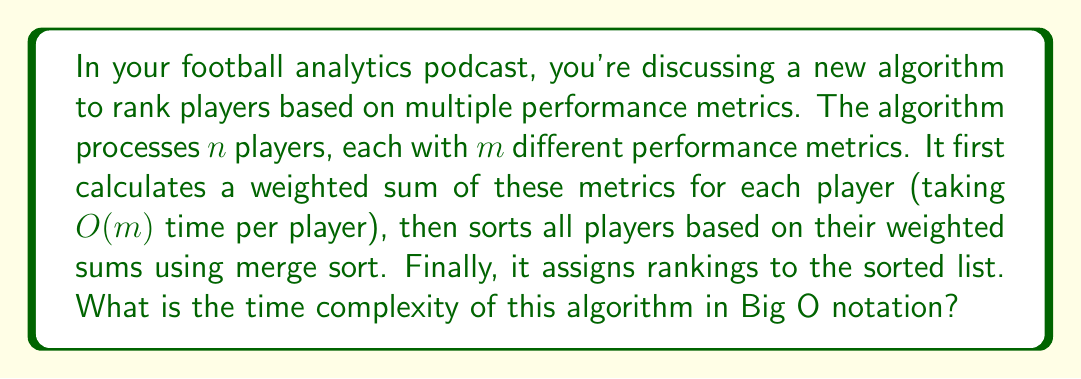Provide a solution to this math problem. Let's break down the algorithm and analyze its time complexity step by step:

1. Calculating weighted sums:
   - For each of the $n$ players, we perform $m$ operations to calculate the weighted sum.
   - Time complexity for this step: $O(n * m)$

2. Sorting players using merge sort:
   - Merge sort has a time complexity of $O(n \log n)$ for $n$ elements.
   - Time complexity for this step: $O(n \log n)$

3. Assigning rankings:
   - This is a simple linear pass through the sorted list.
   - Time complexity for this step: $O(n)$

To determine the overall time complexity, we need to sum these steps:

$$T(n, m) = O(n * m) + O(n \log n) + O(n)$$

Simplifying:
$$T(n, m) = O(n * m + n \log n + n)$$

Now, we need to determine which term dominates as $n$ and $m$ grow large. There are two cases to consider:

Case 1: If $m \geq \log n$
- $n * m$ will dominate $n \log n$ and $n$
- The time complexity will be $O(n * m)$

Case 2: If $m < \log n$
- $n \log n$ will dominate $n * m$ and $n$
- The time complexity will be $O(n \log n)$

Therefore, the overall time complexity can be expressed as:

$$O(\max(n * m, n \log n))$$

This means the algorithm's time complexity is the maximum of $O(n * m)$ and $O(n \log n)$.
Answer: $O(\max(n * m, n \log n))$ 